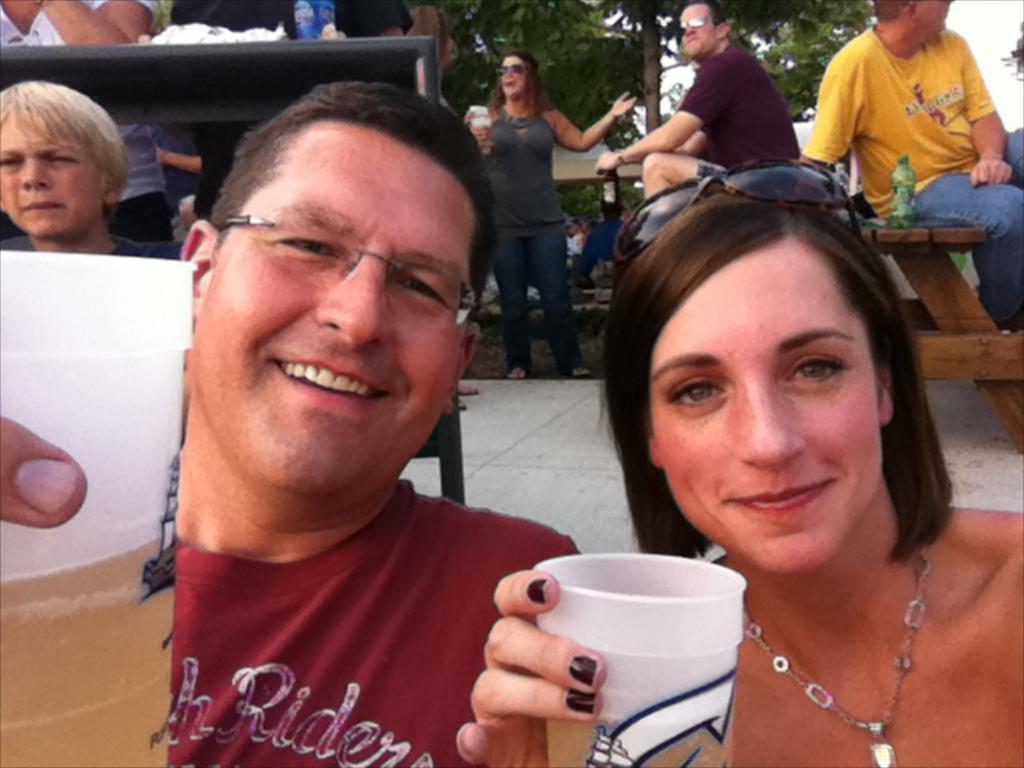Please provide a concise description of this image. In the image we can see there are many people are standing and some of them are sitting. They are wearing clothes, these are the spectacles, neck chain, glass, bench, bottle, tree and a sky. This is a footpath and we can even see these two people are smiling. 